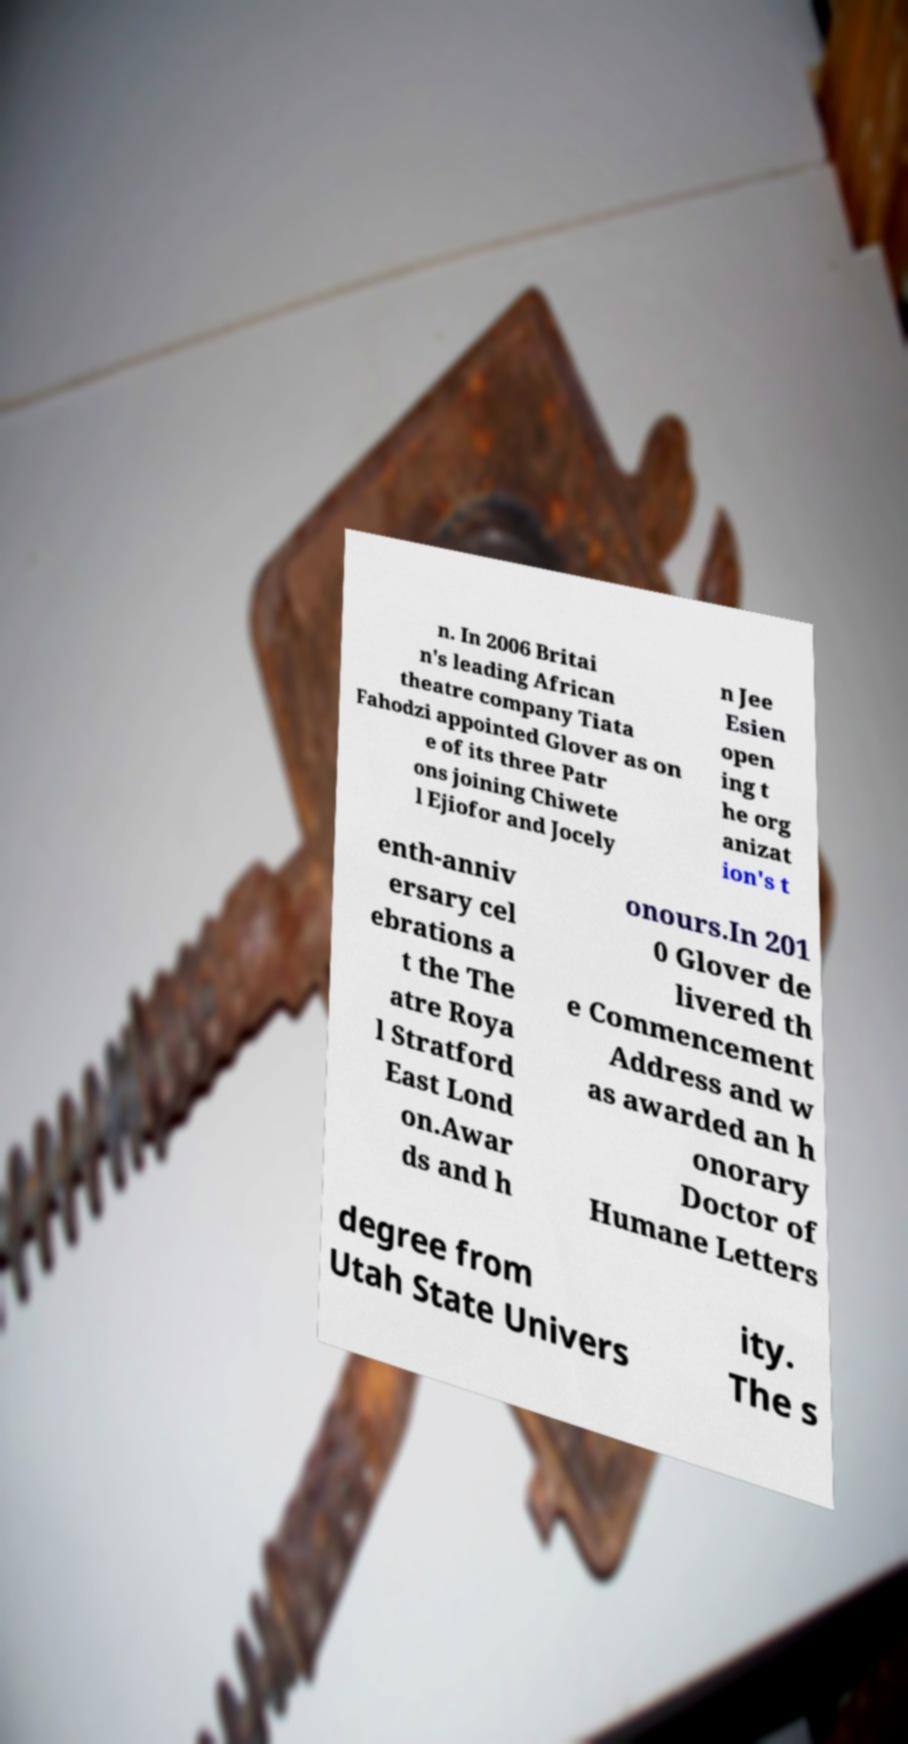Can you accurately transcribe the text from the provided image for me? n. In 2006 Britai n's leading African theatre company Tiata Fahodzi appointed Glover as on e of its three Patr ons joining Chiwete l Ejiofor and Jocely n Jee Esien open ing t he org anizat ion's t enth-anniv ersary cel ebrations a t the The atre Roya l Stratford East Lond on.Awar ds and h onours.In 201 0 Glover de livered th e Commencement Address and w as awarded an h onorary Doctor of Humane Letters degree from Utah State Univers ity. The s 